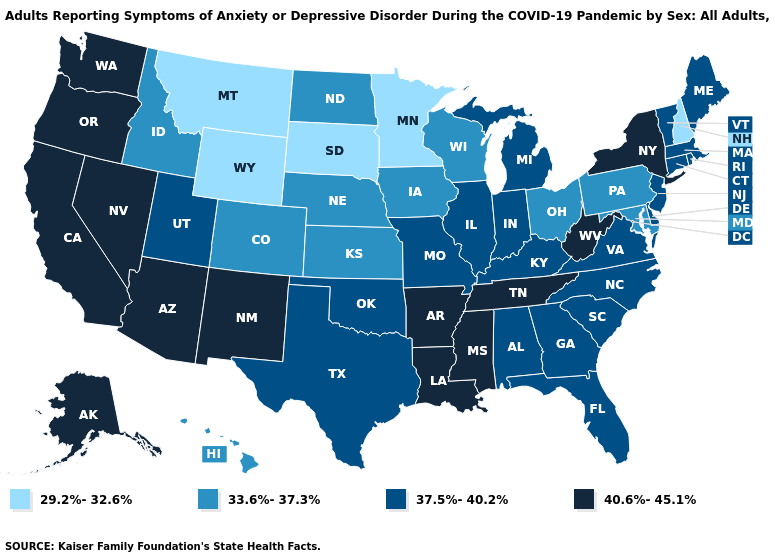Does Oregon have the highest value in the USA?
Answer briefly. Yes. Which states have the highest value in the USA?
Short answer required. Alaska, Arizona, Arkansas, California, Louisiana, Mississippi, Nevada, New Mexico, New York, Oregon, Tennessee, Washington, West Virginia. Among the states that border New Mexico , does Colorado have the lowest value?
Keep it brief. Yes. What is the value of Tennessee?
Short answer required. 40.6%-45.1%. What is the highest value in the Northeast ?
Be succinct. 40.6%-45.1%. What is the value of New Jersey?
Answer briefly. 37.5%-40.2%. Does Louisiana have a higher value than Oregon?
Keep it brief. No. What is the lowest value in the USA?
Keep it brief. 29.2%-32.6%. Name the states that have a value in the range 37.5%-40.2%?
Answer briefly. Alabama, Connecticut, Delaware, Florida, Georgia, Illinois, Indiana, Kentucky, Maine, Massachusetts, Michigan, Missouri, New Jersey, North Carolina, Oklahoma, Rhode Island, South Carolina, Texas, Utah, Vermont, Virginia. What is the value of Iowa?
Quick response, please. 33.6%-37.3%. What is the value of Virginia?
Answer briefly. 37.5%-40.2%. Among the states that border Vermont , which have the highest value?
Give a very brief answer. New York. What is the value of Rhode Island?
Write a very short answer. 37.5%-40.2%. What is the lowest value in the Northeast?
Write a very short answer. 29.2%-32.6%. Does Pennsylvania have the highest value in the Northeast?
Concise answer only. No. 